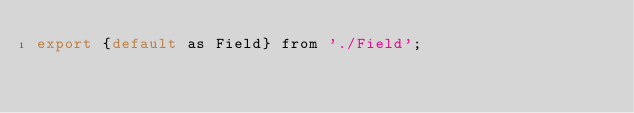<code> <loc_0><loc_0><loc_500><loc_500><_JavaScript_>export {default as Field} from './Field';</code> 